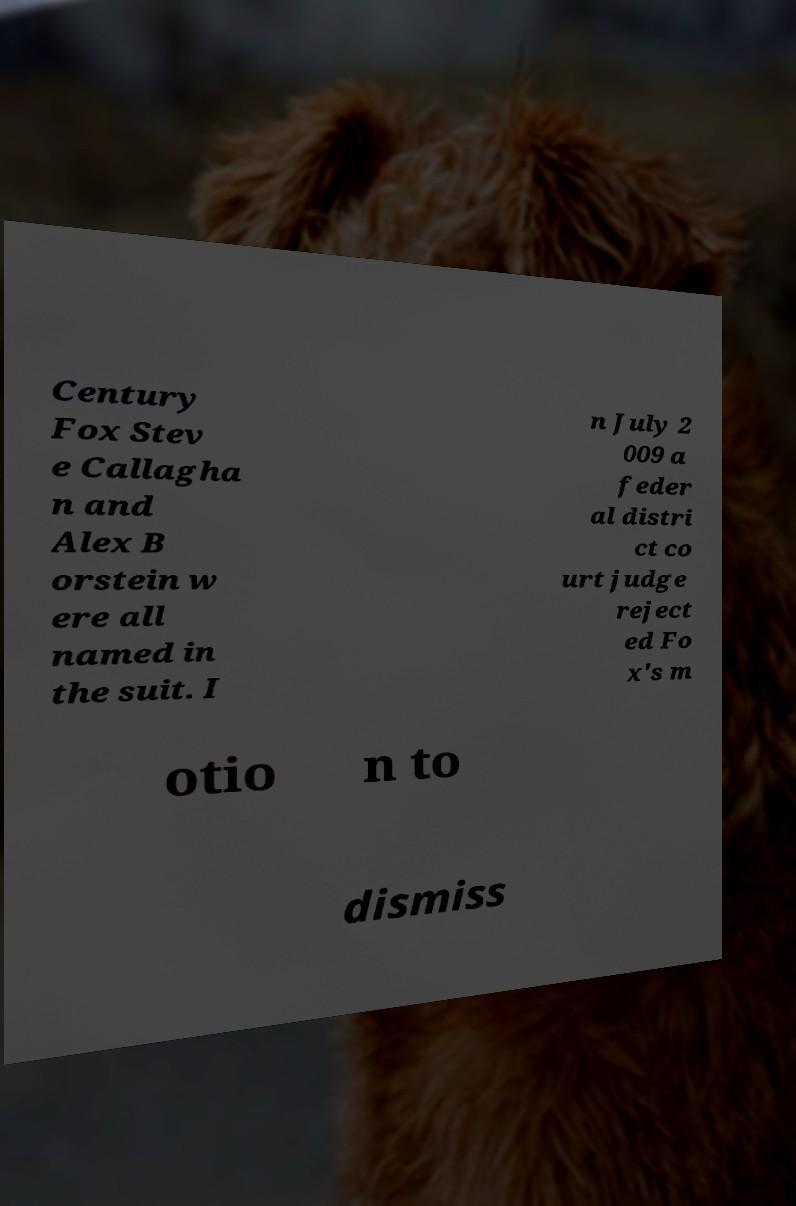Can you read and provide the text displayed in the image?This photo seems to have some interesting text. Can you extract and type it out for me? Century Fox Stev e Callagha n and Alex B orstein w ere all named in the suit. I n July 2 009 a feder al distri ct co urt judge reject ed Fo x's m otio n to dismiss 